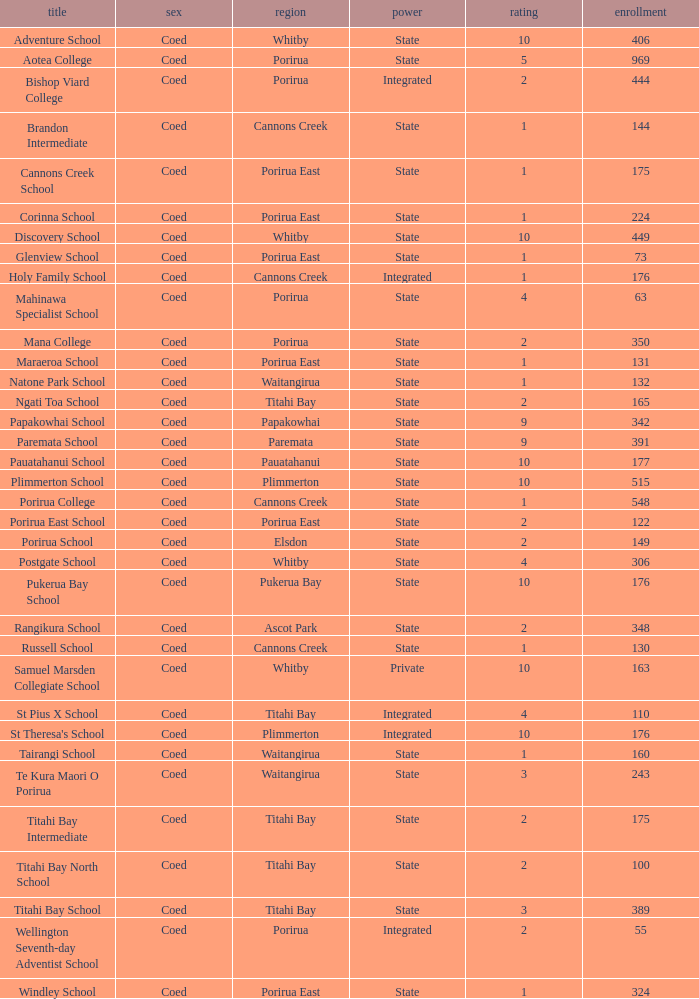What is the roll of Bishop Viard College (An Integrated College), which has a decile larger than 1? 1.0. 